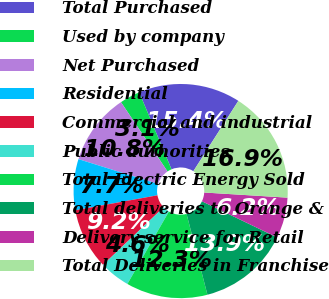Convert chart. <chart><loc_0><loc_0><loc_500><loc_500><pie_chart><fcel>Total Purchased<fcel>Used by company<fcel>Net Purchased<fcel>Residential<fcel>Commercial and industrial<fcel>Public authorities<fcel>Total Electric Energy Sold<fcel>Total deliveries to Orange &<fcel>Delivery service for Retail<fcel>Total Deliveries in Franchise<nl><fcel>15.39%<fcel>3.08%<fcel>10.77%<fcel>7.69%<fcel>9.23%<fcel>4.61%<fcel>12.31%<fcel>13.85%<fcel>6.15%<fcel>16.92%<nl></chart> 